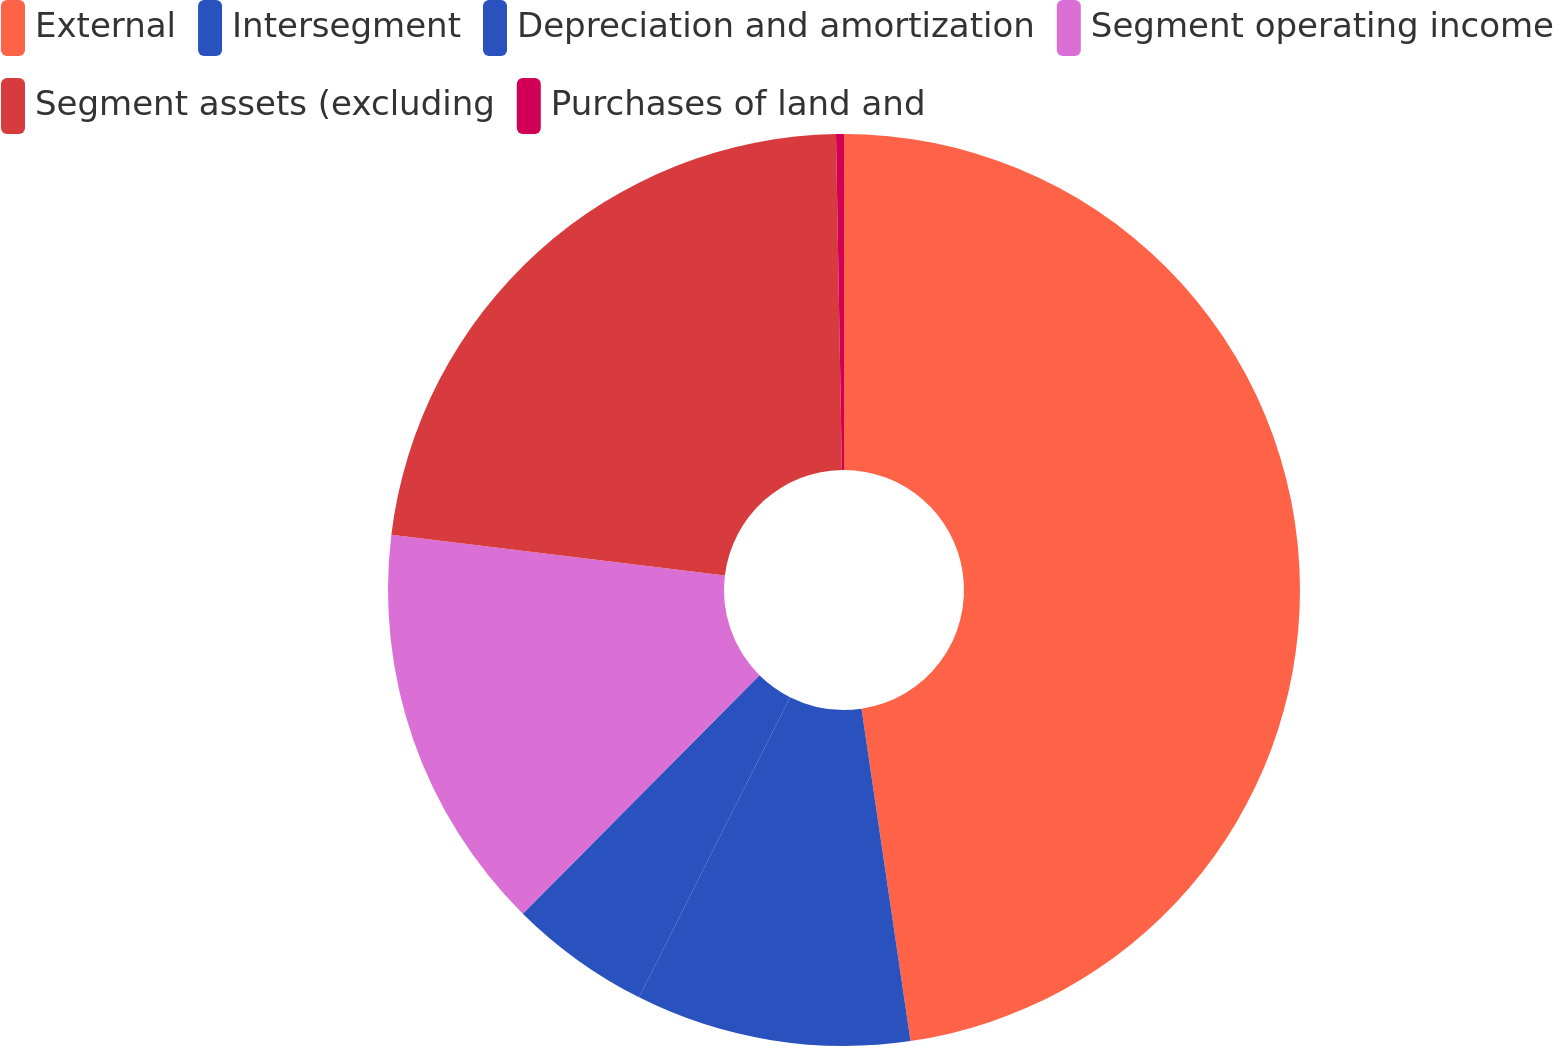Convert chart to OTSL. <chart><loc_0><loc_0><loc_500><loc_500><pie_chart><fcel>External<fcel>Intersegment<fcel>Depreciation and amortization<fcel>Segment operating income<fcel>Segment assets (excluding<fcel>Purchases of land and<nl><fcel>47.67%<fcel>9.75%<fcel>5.02%<fcel>14.49%<fcel>22.79%<fcel>0.28%<nl></chart> 